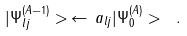<formula> <loc_0><loc_0><loc_500><loc_500>| \Psi ^ { ( A - 1 ) } _ { l j } > \, \leftarrow \, a _ { l j } | \Psi ^ { ( A ) } _ { 0 } > \ .</formula> 